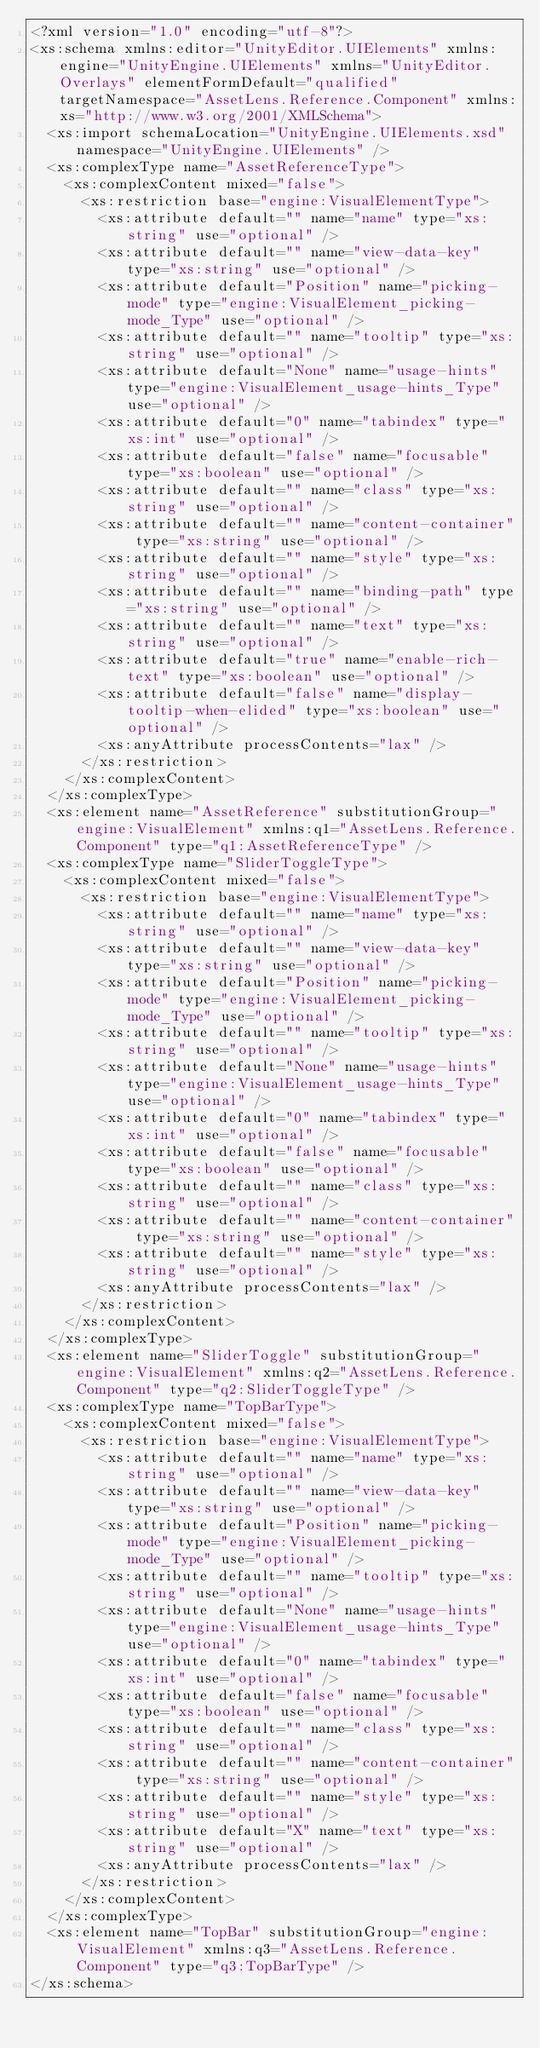<code> <loc_0><loc_0><loc_500><loc_500><_XML_><?xml version="1.0" encoding="utf-8"?>
<xs:schema xmlns:editor="UnityEditor.UIElements" xmlns:engine="UnityEngine.UIElements" xmlns="UnityEditor.Overlays" elementFormDefault="qualified" targetNamespace="AssetLens.Reference.Component" xmlns:xs="http://www.w3.org/2001/XMLSchema">
  <xs:import schemaLocation="UnityEngine.UIElements.xsd" namespace="UnityEngine.UIElements" />
  <xs:complexType name="AssetReferenceType">
    <xs:complexContent mixed="false">
      <xs:restriction base="engine:VisualElementType">
        <xs:attribute default="" name="name" type="xs:string" use="optional" />
        <xs:attribute default="" name="view-data-key" type="xs:string" use="optional" />
        <xs:attribute default="Position" name="picking-mode" type="engine:VisualElement_picking-mode_Type" use="optional" />
        <xs:attribute default="" name="tooltip" type="xs:string" use="optional" />
        <xs:attribute default="None" name="usage-hints" type="engine:VisualElement_usage-hints_Type" use="optional" />
        <xs:attribute default="0" name="tabindex" type="xs:int" use="optional" />
        <xs:attribute default="false" name="focusable" type="xs:boolean" use="optional" />
        <xs:attribute default="" name="class" type="xs:string" use="optional" />
        <xs:attribute default="" name="content-container" type="xs:string" use="optional" />
        <xs:attribute default="" name="style" type="xs:string" use="optional" />
        <xs:attribute default="" name="binding-path" type="xs:string" use="optional" />
        <xs:attribute default="" name="text" type="xs:string" use="optional" />
        <xs:attribute default="true" name="enable-rich-text" type="xs:boolean" use="optional" />
        <xs:attribute default="false" name="display-tooltip-when-elided" type="xs:boolean" use="optional" />
        <xs:anyAttribute processContents="lax" />
      </xs:restriction>
    </xs:complexContent>
  </xs:complexType>
  <xs:element name="AssetReference" substitutionGroup="engine:VisualElement" xmlns:q1="AssetLens.Reference.Component" type="q1:AssetReferenceType" />
  <xs:complexType name="SliderToggleType">
    <xs:complexContent mixed="false">
      <xs:restriction base="engine:VisualElementType">
        <xs:attribute default="" name="name" type="xs:string" use="optional" />
        <xs:attribute default="" name="view-data-key" type="xs:string" use="optional" />
        <xs:attribute default="Position" name="picking-mode" type="engine:VisualElement_picking-mode_Type" use="optional" />
        <xs:attribute default="" name="tooltip" type="xs:string" use="optional" />
        <xs:attribute default="None" name="usage-hints" type="engine:VisualElement_usage-hints_Type" use="optional" />
        <xs:attribute default="0" name="tabindex" type="xs:int" use="optional" />
        <xs:attribute default="false" name="focusable" type="xs:boolean" use="optional" />
        <xs:attribute default="" name="class" type="xs:string" use="optional" />
        <xs:attribute default="" name="content-container" type="xs:string" use="optional" />
        <xs:attribute default="" name="style" type="xs:string" use="optional" />
        <xs:anyAttribute processContents="lax" />
      </xs:restriction>
    </xs:complexContent>
  </xs:complexType>
  <xs:element name="SliderToggle" substitutionGroup="engine:VisualElement" xmlns:q2="AssetLens.Reference.Component" type="q2:SliderToggleType" />
  <xs:complexType name="TopBarType">
    <xs:complexContent mixed="false">
      <xs:restriction base="engine:VisualElementType">
        <xs:attribute default="" name="name" type="xs:string" use="optional" />
        <xs:attribute default="" name="view-data-key" type="xs:string" use="optional" />
        <xs:attribute default="Position" name="picking-mode" type="engine:VisualElement_picking-mode_Type" use="optional" />
        <xs:attribute default="" name="tooltip" type="xs:string" use="optional" />
        <xs:attribute default="None" name="usage-hints" type="engine:VisualElement_usage-hints_Type" use="optional" />
        <xs:attribute default="0" name="tabindex" type="xs:int" use="optional" />
        <xs:attribute default="false" name="focusable" type="xs:boolean" use="optional" />
        <xs:attribute default="" name="class" type="xs:string" use="optional" />
        <xs:attribute default="" name="content-container" type="xs:string" use="optional" />
        <xs:attribute default="" name="style" type="xs:string" use="optional" />
        <xs:attribute default="X" name="text" type="xs:string" use="optional" />
        <xs:anyAttribute processContents="lax" />
      </xs:restriction>
    </xs:complexContent>
  </xs:complexType>
  <xs:element name="TopBar" substitutionGroup="engine:VisualElement" xmlns:q3="AssetLens.Reference.Component" type="q3:TopBarType" />
</xs:schema></code> 